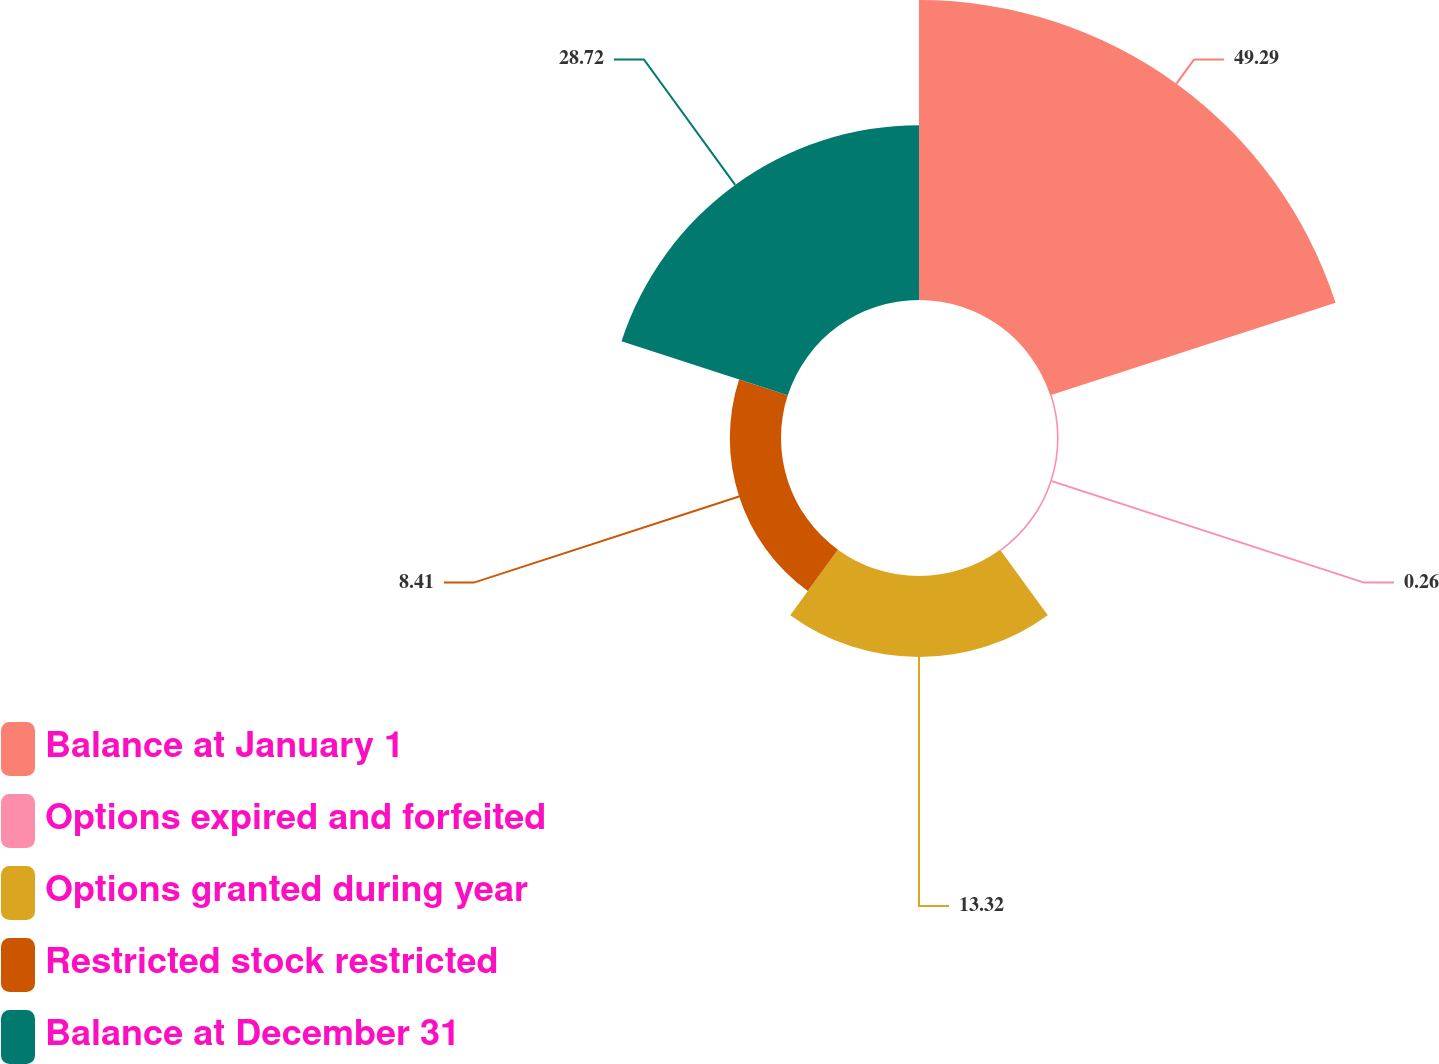Convert chart to OTSL. <chart><loc_0><loc_0><loc_500><loc_500><pie_chart><fcel>Balance at January 1<fcel>Options expired and forfeited<fcel>Options granted during year<fcel>Restricted stock restricted<fcel>Balance at December 31<nl><fcel>49.29%<fcel>0.26%<fcel>13.32%<fcel>8.41%<fcel>28.72%<nl></chart> 